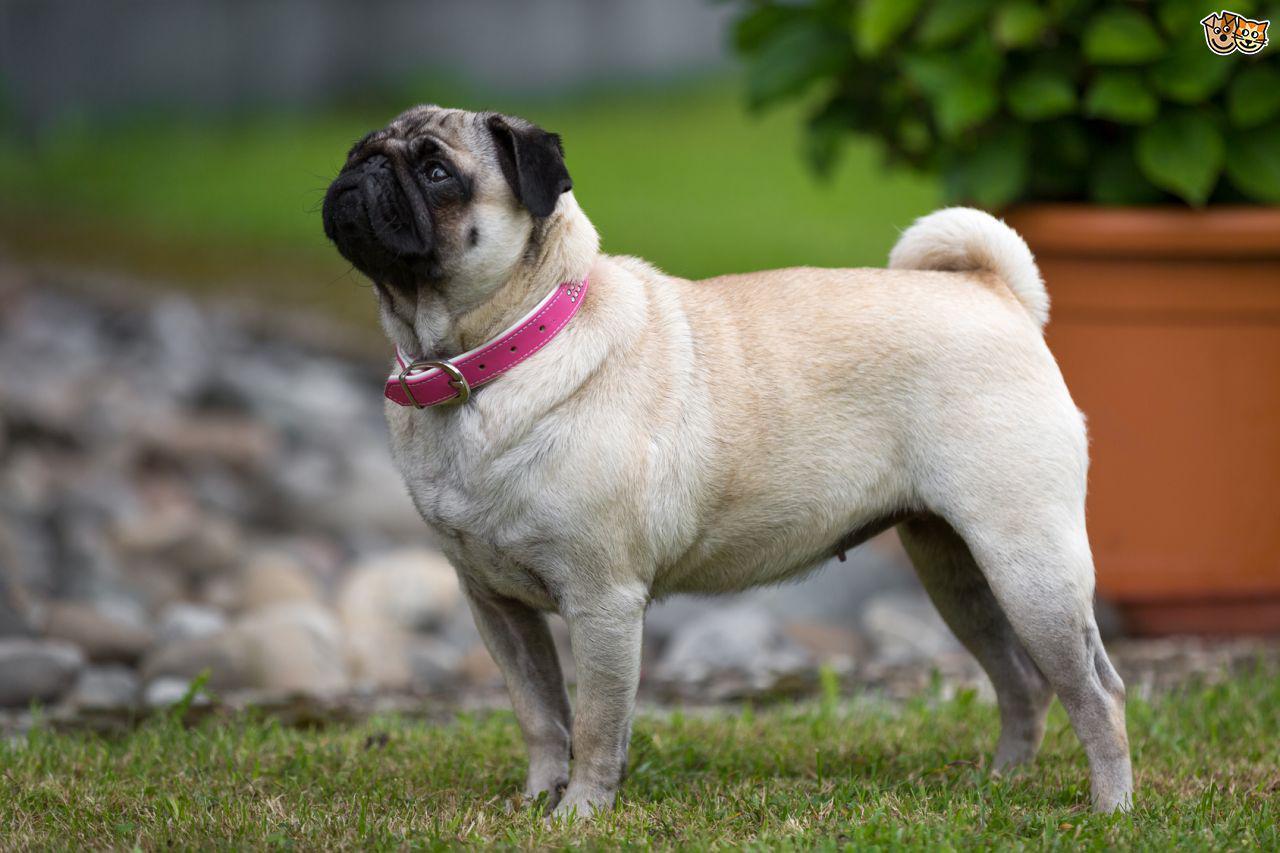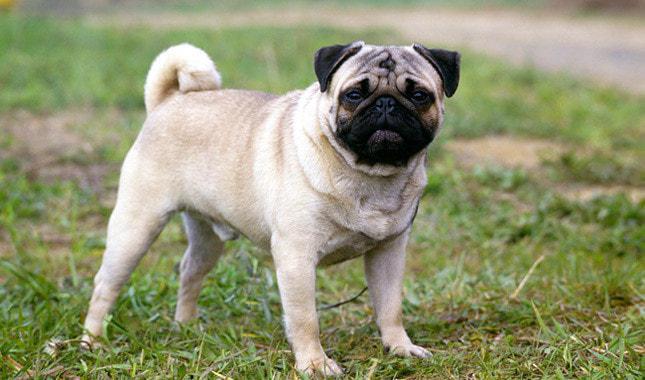The first image is the image on the left, the second image is the image on the right. For the images shown, is this caption "In the image on the right, there is a dog with a stick in the dog's mouth." true? Answer yes or no. No. 